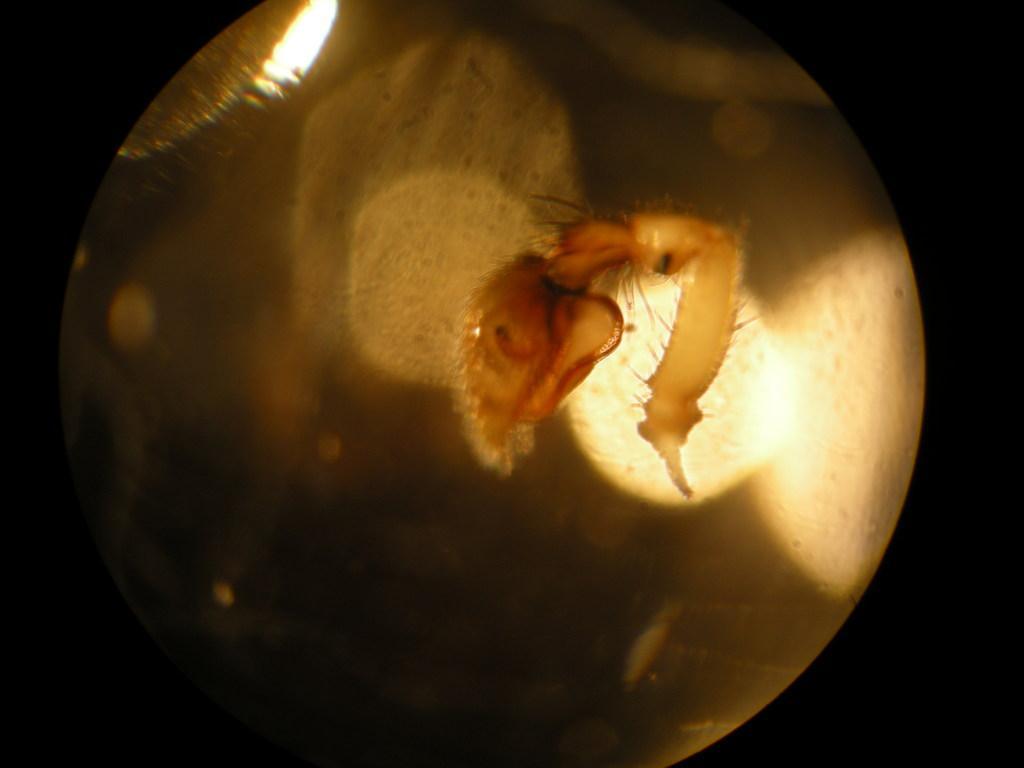Could you give a brief overview of what you see in this image? In this image, it seems like an insect in the foreground area and there is light in the background. 